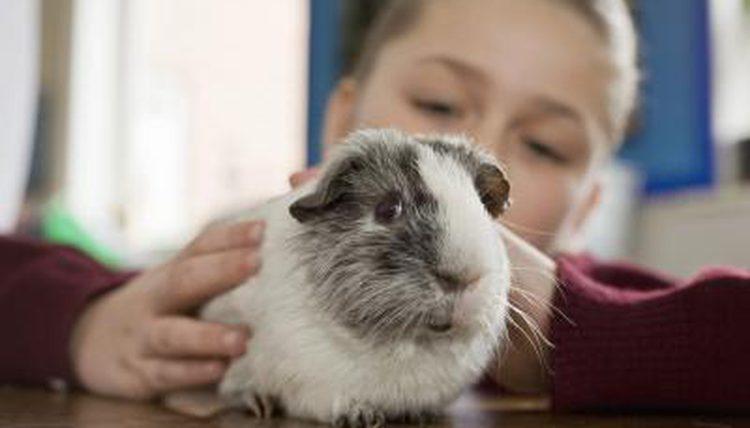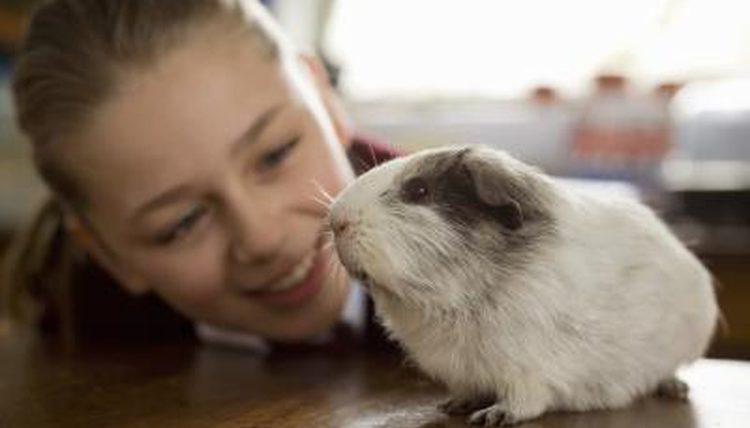The first image is the image on the left, the second image is the image on the right. Considering the images on both sides, is "There is no brown fur on these guinea pigs." valid? Answer yes or no. Yes. 